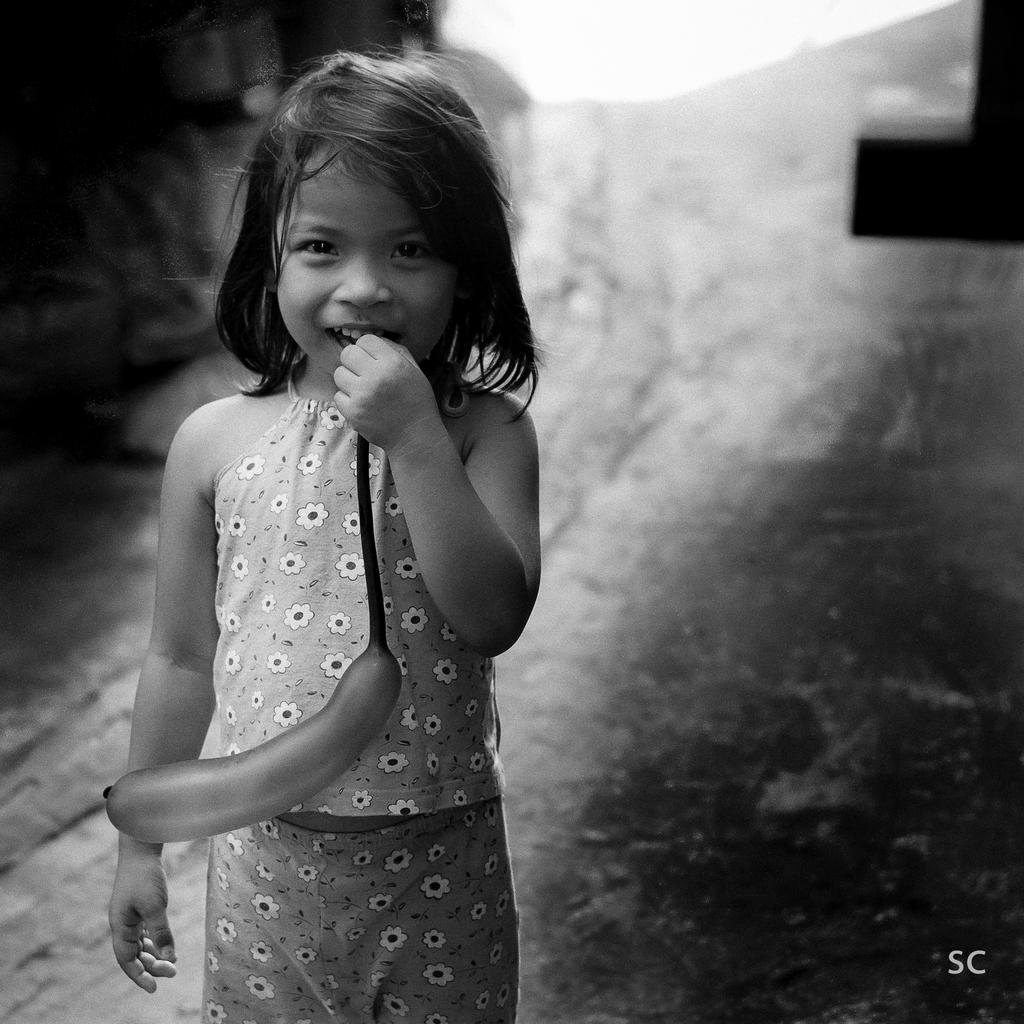What is the color scheme of the image? The image is black and white. Who is present in the image? There is a girl in the image. What is the girl doing in the image? The girl is standing on the floor. What object is the girl holding in the image? The girl has a balloon in her mouth. What type of glue is the girl using to attach the fly to the wall in the image? There is no glue or fly present in the image; it only features a girl standing on the floor with a balloon in her mouth. 